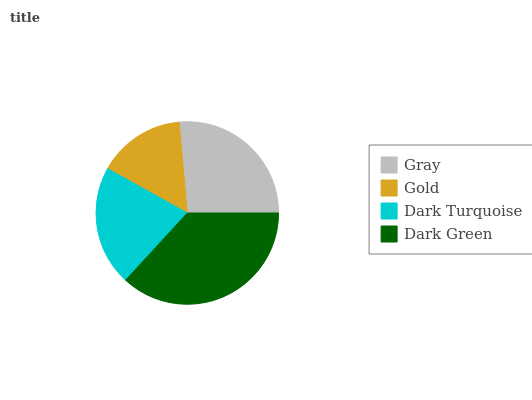Is Gold the minimum?
Answer yes or no. Yes. Is Dark Green the maximum?
Answer yes or no. Yes. Is Dark Turquoise the minimum?
Answer yes or no. No. Is Dark Turquoise the maximum?
Answer yes or no. No. Is Dark Turquoise greater than Gold?
Answer yes or no. Yes. Is Gold less than Dark Turquoise?
Answer yes or no. Yes. Is Gold greater than Dark Turquoise?
Answer yes or no. No. Is Dark Turquoise less than Gold?
Answer yes or no. No. Is Gray the high median?
Answer yes or no. Yes. Is Dark Turquoise the low median?
Answer yes or no. Yes. Is Gold the high median?
Answer yes or no. No. Is Dark Green the low median?
Answer yes or no. No. 